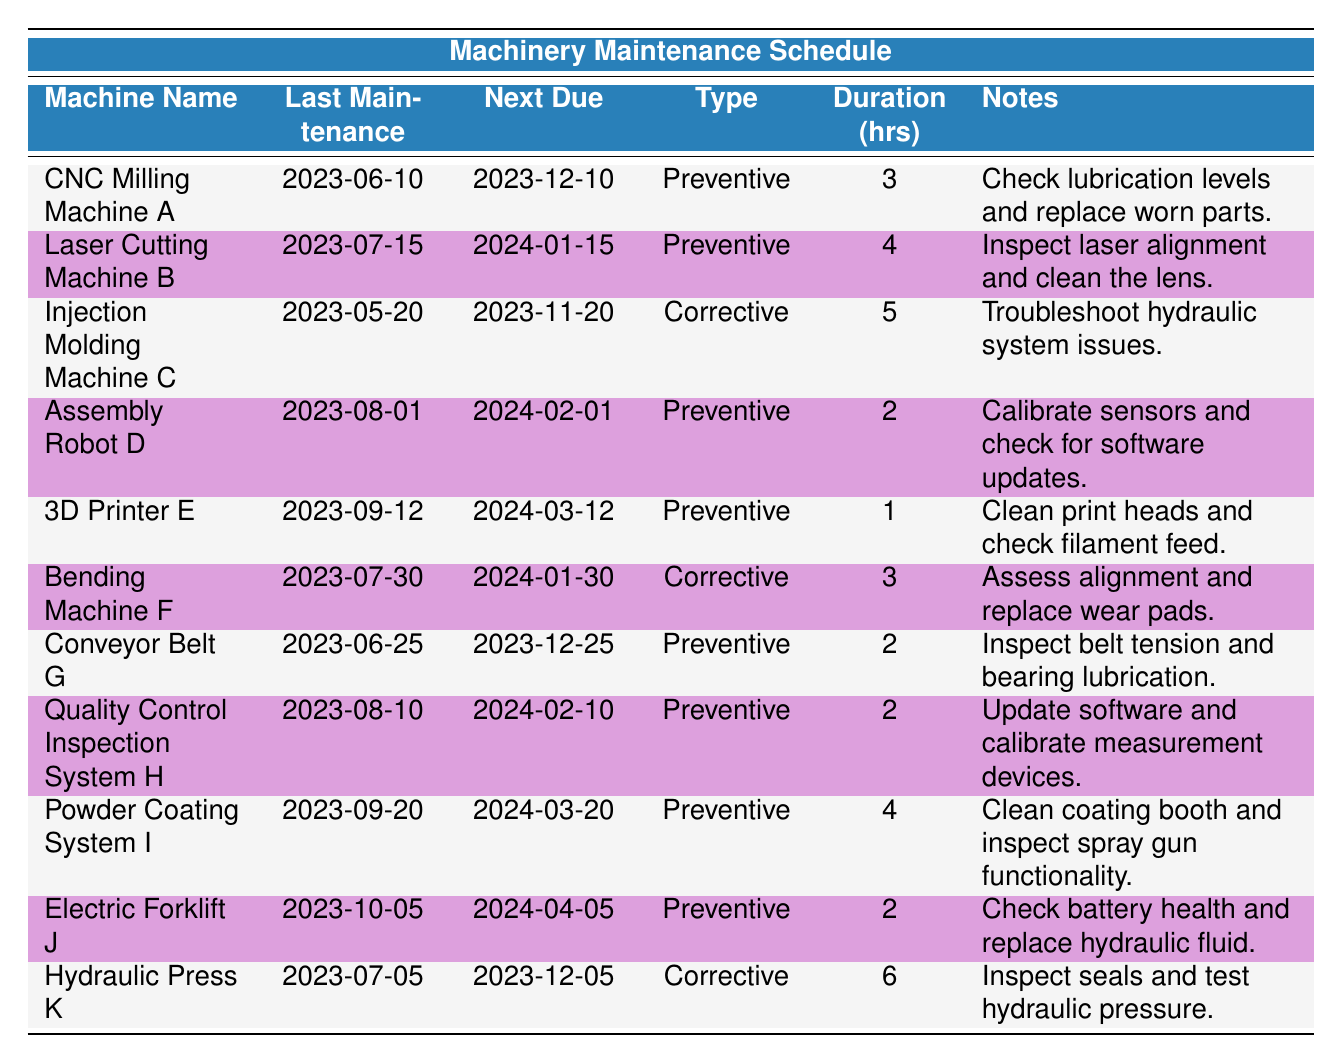What type of maintenance is due for the 3D Printer E? The "maintenance_type" column indicates that the 3D Printer E is due for "Preventive" maintenance.
Answer: Preventive When is the next maintenance due for the CNC Milling Machine A? The "next_maintenance_due" column shows that the CNC Milling Machine A's next maintenance is due on "2023-12-10".
Answer: 2023-12-10 Which machine has the longest maintenance duration and what is the duration? Comparing the "duration_hours" for all machines, the Hydraulic Press K has the longest duration, which is 6 hours.
Answer: 6 hours Is the last maintenance date for the Electric Forklift J more recent than that of the Laser Cutting Machine B? The last maintenance date for Electric Forklift J is "2023-10-05", while for Laser Cutting Machine B it is "2023-07-15". Since "2023-10-05" is after "2023-07-15", the statement is true.
Answer: Yes What is the average duration of preventive maintenance across all preventive maintenance machines? The machines with preventive maintenance are: CNC Milling Machine A (3 hours), Laser Cutting Machine B (4 hours), Assembly Robot D (2 hours), 3D Printer E (1 hour), Conveyor Belt G (2 hours), Quality Control Inspection System H (2 hours), Powder Coating System I (4 hours), and Electric Forklift J (2 hours). Summing these gives 18 hours and dividing by 8 (the number of preventive maintenance machines) results in an average of 2.25 hours.
Answer: 2.25 hours How many machines have corrective maintenance scheduled? From the table, there are 3 machines with corrective maintenance, which are Injection Molding Machine C, Bending Machine F, and Hydraulic Press K.
Answer: 3 machines Which machine has the next maintenance due after January 2024? By checking the "next_maintenance_due" dates, the next due date after January 2024 is for Electric Forklift J on "2024-04-05".
Answer: Electric Forklift J Is the next maintenance of the Injection Molding Machine C due before or after the next maintenance of the Conveyor Belt G? The next maintenance of the Injection Molding Machine C is due on "2023-11-20" and that of the Conveyor Belt G is due on "2023-12-25". Since "2023-11-20" is before "2023-12-25", the answer is before.
Answer: Before 